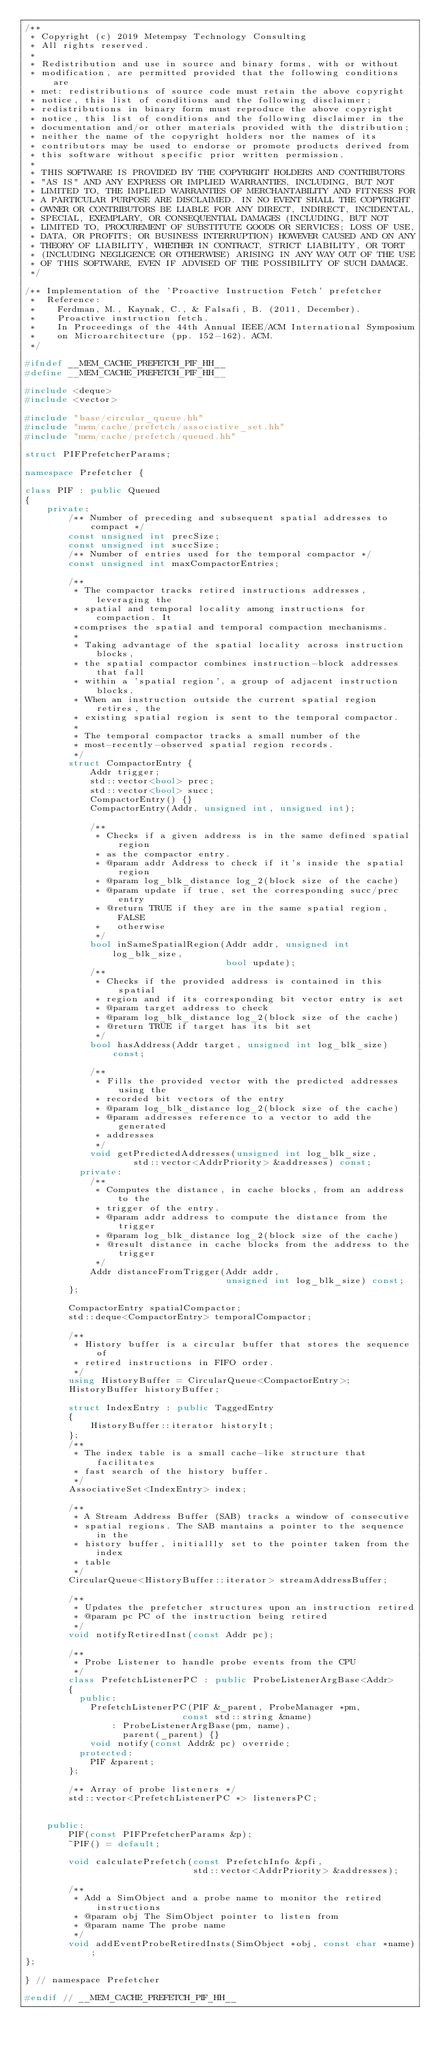<code> <loc_0><loc_0><loc_500><loc_500><_C++_>/**
 * Copyright (c) 2019 Metempsy Technology Consulting
 * All rights reserved.
 *
 * Redistribution and use in source and binary forms, with or without
 * modification, are permitted provided that the following conditions are
 * met: redistributions of source code must retain the above copyright
 * notice, this list of conditions and the following disclaimer;
 * redistributions in binary form must reproduce the above copyright
 * notice, this list of conditions and the following disclaimer in the
 * documentation and/or other materials provided with the distribution;
 * neither the name of the copyright holders nor the names of its
 * contributors may be used to endorse or promote products derived from
 * this software without specific prior written permission.
 *
 * THIS SOFTWARE IS PROVIDED BY THE COPYRIGHT HOLDERS AND CONTRIBUTORS
 * "AS IS" AND ANY EXPRESS OR IMPLIED WARRANTIES, INCLUDING, BUT NOT
 * LIMITED TO, THE IMPLIED WARRANTIES OF MERCHANTABILITY AND FITNESS FOR
 * A PARTICULAR PURPOSE ARE DISCLAIMED. IN NO EVENT SHALL THE COPYRIGHT
 * OWNER OR CONTRIBUTORS BE LIABLE FOR ANY DIRECT, INDIRECT, INCIDENTAL,
 * SPECIAL, EXEMPLARY, OR CONSEQUENTIAL DAMAGES (INCLUDING, BUT NOT
 * LIMITED TO, PROCUREMENT OF SUBSTITUTE GOODS OR SERVICES; LOSS OF USE,
 * DATA, OR PROFITS; OR BUSINESS INTERRUPTION) HOWEVER CAUSED AND ON ANY
 * THEORY OF LIABILITY, WHETHER IN CONTRACT, STRICT LIABILITY, OR TORT
 * (INCLUDING NEGLIGENCE OR OTHERWISE) ARISING IN ANY WAY OUT OF THE USE
 * OF THIS SOFTWARE, EVEN IF ADVISED OF THE POSSIBILITY OF SUCH DAMAGE.
 */

/** Implementation of the 'Proactive Instruction Fetch' prefetcher
 *  Reference:
 *    Ferdman, M., Kaynak, C., & Falsafi, B. (2011, December).
 *    Proactive instruction fetch.
 *    In Proceedings of the 44th Annual IEEE/ACM International Symposium
 *    on Microarchitecture (pp. 152-162). ACM.
 */

#ifndef __MEM_CACHE_PREFETCH_PIF_HH__
#define __MEM_CACHE_PREFETCH_PIF_HH__

#include <deque>
#include <vector>

#include "base/circular_queue.hh"
#include "mem/cache/prefetch/associative_set.hh"
#include "mem/cache/prefetch/queued.hh"

struct PIFPrefetcherParams;

namespace Prefetcher {

class PIF : public Queued
{
    private:
        /** Number of preceding and subsequent spatial addresses to compact */
        const unsigned int precSize;
        const unsigned int succSize;
        /** Number of entries used for the temporal compactor */
        const unsigned int maxCompactorEntries;

        /**
         * The compactor tracks retired instructions addresses, leveraging the
         * spatial and temporal locality among instructions for compaction. It
         *comprises the spatial and temporal compaction mechanisms.
         *
         * Taking advantage of the spatial locality across instruction blocks,
         * the spatial compactor combines instruction-block addresses that fall
         * within a 'spatial region', a group of adjacent instruction blocks.
         * When an instruction outside the current spatial region retires, the
         * existing spatial region is sent to the temporal compactor.
         *
         * The temporal compactor tracks a small number of the
         * most-recently-observed spatial region records.
         */
        struct CompactorEntry {
            Addr trigger;
            std::vector<bool> prec;
            std::vector<bool> succ;
            CompactorEntry() {}
            CompactorEntry(Addr, unsigned int, unsigned int);

            /**
             * Checks if a given address is in the same defined spatial region
             * as the compactor entry.
             * @param addr Address to check if it's inside the spatial region
             * @param log_blk_distance log_2(block size of the cache)
             * @param update if true, set the corresponding succ/prec entry
             * @return TRUE if they are in the same spatial region, FALSE
             *   otherwise
             */
            bool inSameSpatialRegion(Addr addr, unsigned int log_blk_size,
                                     bool update);
            /**
             * Checks if the provided address is contained in this spatial
             * region and if its corresponding bit vector entry is set
             * @param target address to check
             * @param log_blk_distance log_2(block size of the cache)
             * @return TRUE if target has its bit set
             */
            bool hasAddress(Addr target, unsigned int log_blk_size) const;

            /**
             * Fills the provided vector with the predicted addresses using the
             * recorded bit vectors of the entry
             * @param log_blk_distance log_2(block size of the cache)
             * @param addresses reference to a vector to add the generated
             * addresses
             */
            void getPredictedAddresses(unsigned int log_blk_size,
                    std::vector<AddrPriority> &addresses) const;
          private:
            /**
             * Computes the distance, in cache blocks, from an address to the
             * trigger of the entry.
             * @param addr address to compute the distance from the trigger
             * @param log_blk_distance log_2(block size of the cache)
             * @result distance in cache blocks from the address to the trigger
             */
            Addr distanceFromTrigger(Addr addr,
                                     unsigned int log_blk_size) const;
        };

        CompactorEntry spatialCompactor;
        std::deque<CompactorEntry> temporalCompactor;

        /**
         * History buffer is a circular buffer that stores the sequence of
         * retired instructions in FIFO order.
         */
        using HistoryBuffer = CircularQueue<CompactorEntry>;
        HistoryBuffer historyBuffer;

        struct IndexEntry : public TaggedEntry
        {
            HistoryBuffer::iterator historyIt;
        };
        /**
         * The index table is a small cache-like structure that facilitates
         * fast search of the history buffer.
         */
        AssociativeSet<IndexEntry> index;

        /**
         * A Stream Address Buffer (SAB) tracks a window of consecutive
         * spatial regions. The SAB mantains a pointer to the sequence in the
         * history buffer, initiallly set to the pointer taken from the index
         * table
         */
        CircularQueue<HistoryBuffer::iterator> streamAddressBuffer;

        /**
         * Updates the prefetcher structures upon an instruction retired
         * @param pc PC of the instruction being retired
         */
        void notifyRetiredInst(const Addr pc);

        /**
         * Probe Listener to handle probe events from the CPU
         */
        class PrefetchListenerPC : public ProbeListenerArgBase<Addr>
        {
          public:
            PrefetchListenerPC(PIF &_parent, ProbeManager *pm,
                             const std::string &name)
                : ProbeListenerArgBase(pm, name),
                  parent(_parent) {}
            void notify(const Addr& pc) override;
          protected:
            PIF &parent;
        };

        /** Array of probe listeners */
        std::vector<PrefetchListenerPC *> listenersPC;


    public:
        PIF(const PIFPrefetcherParams &p);
        ~PIF() = default;

        void calculatePrefetch(const PrefetchInfo &pfi,
                               std::vector<AddrPriority> &addresses);

        /**
         * Add a SimObject and a probe name to monitor the retired instructions
         * @param obj The SimObject pointer to listen from
         * @param name The probe name
         */
        void addEventProbeRetiredInsts(SimObject *obj, const char *name);
};

} // namespace Prefetcher

#endif // __MEM_CACHE_PREFETCH_PIF_HH__
</code> 